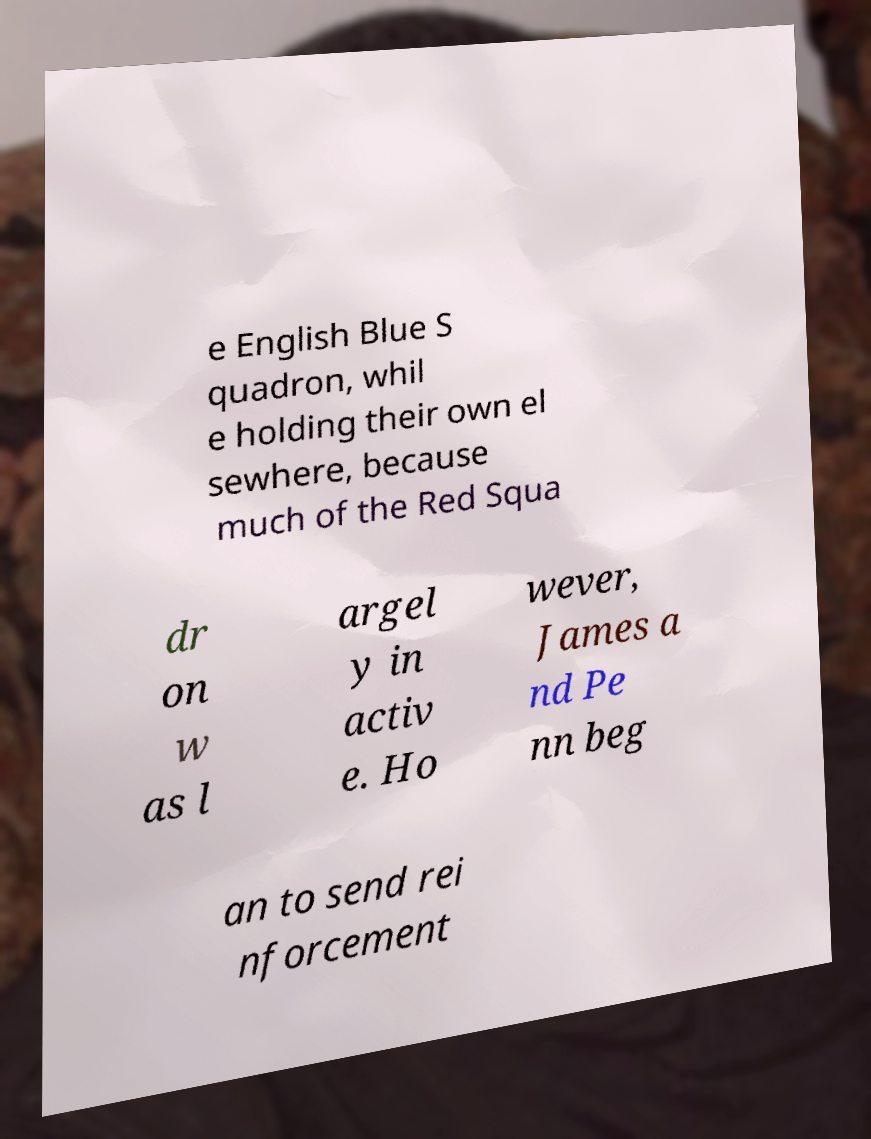Can you read and provide the text displayed in the image?This photo seems to have some interesting text. Can you extract and type it out for me? e English Blue S quadron, whil e holding their own el sewhere, because much of the Red Squa dr on w as l argel y in activ e. Ho wever, James a nd Pe nn beg an to send rei nforcement 